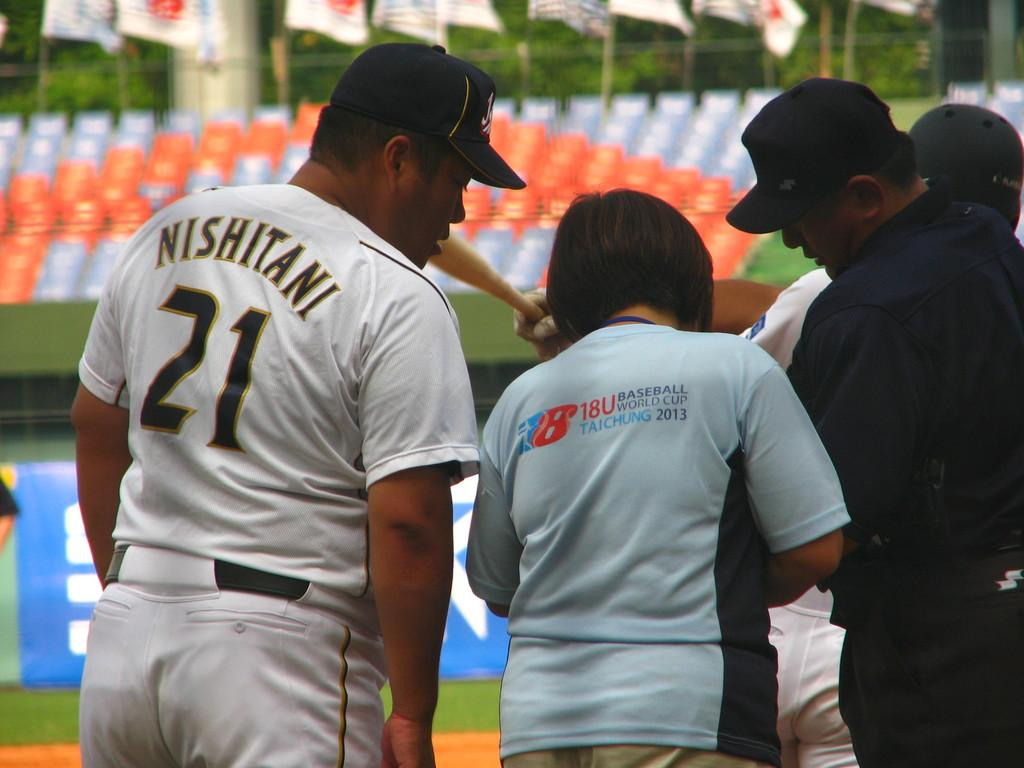<image>
Provide a brief description of the given image. the number 21 is on the back of a man 